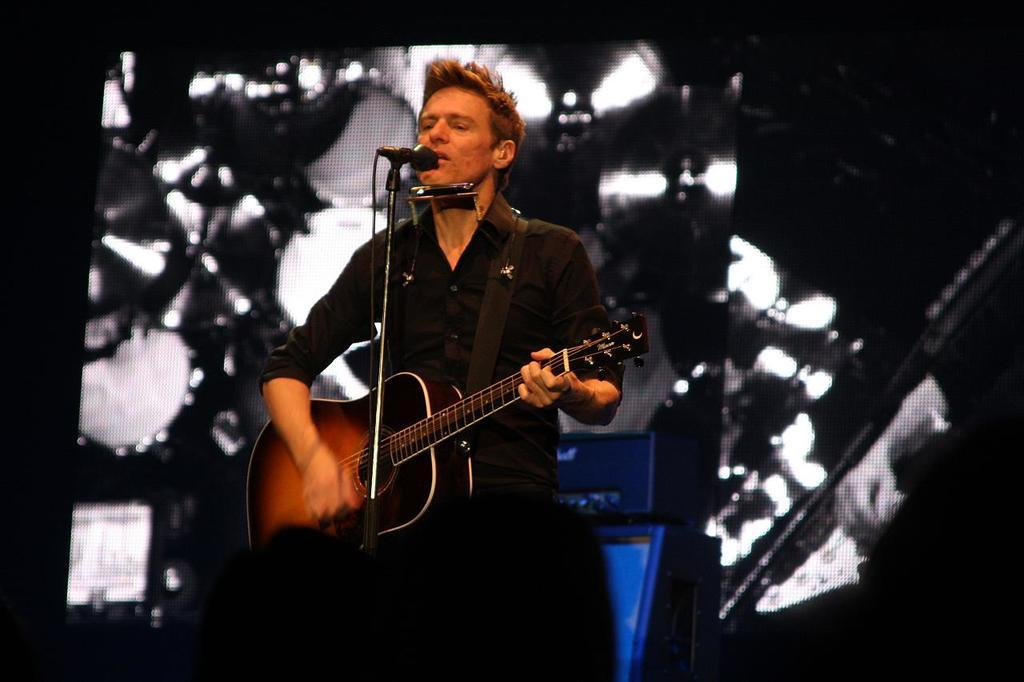What is the man in the image doing? The man is playing a guitar and singing. What is the man holding in the image? The man is holding a guitar and is in front of a microphone. What is the man wearing in the image? The man is wearing a black shirt. What type of cabbage is the man holding in the image? There is no cabbage present in the image; the man is holding a guitar and standing in front of a microphone. 